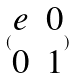<formula> <loc_0><loc_0><loc_500><loc_500>( \begin{matrix} e & 0 \\ 0 & 1 \end{matrix} )</formula> 